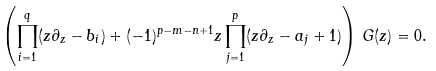<formula> <loc_0><loc_0><loc_500><loc_500>\left ( \prod _ { i = 1 } ^ { q } ( z \partial _ { z } - b _ { i } ) + ( - 1 ) ^ { p - m - n + 1 } z \prod _ { j = 1 } ^ { p } ( z \partial _ { z } - a _ { j } + 1 ) \right ) \, G ( z ) = 0 .</formula> 